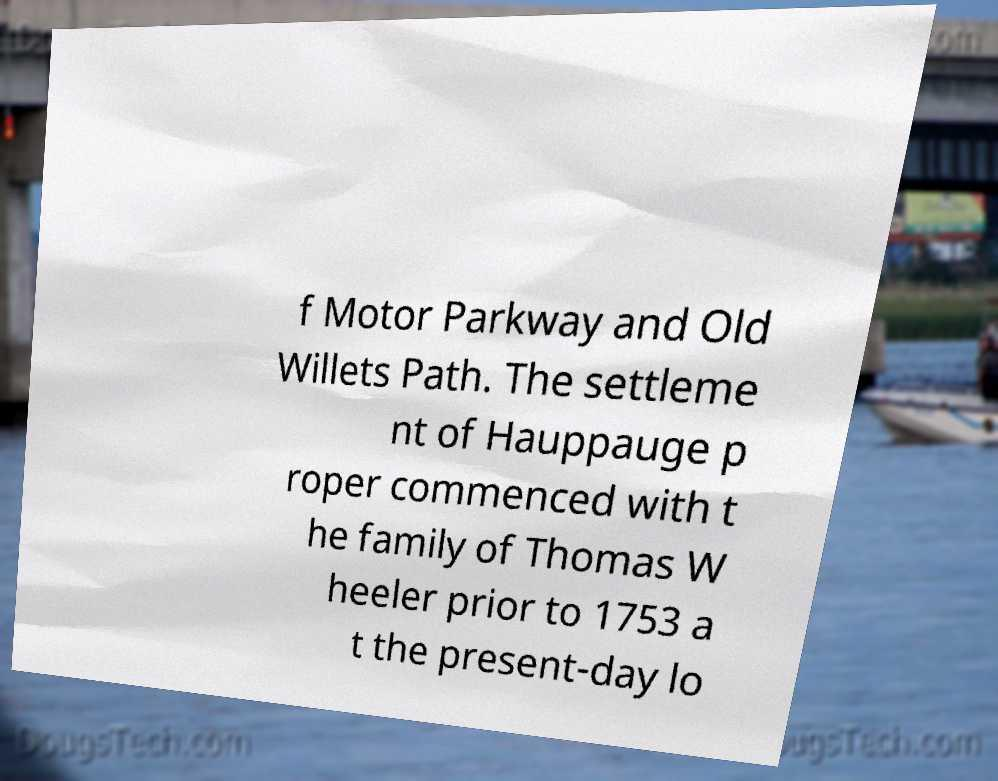I need the written content from this picture converted into text. Can you do that? f Motor Parkway and Old Willets Path. The settleme nt of Hauppauge p roper commenced with t he family of Thomas W heeler prior to 1753 a t the present-day lo 